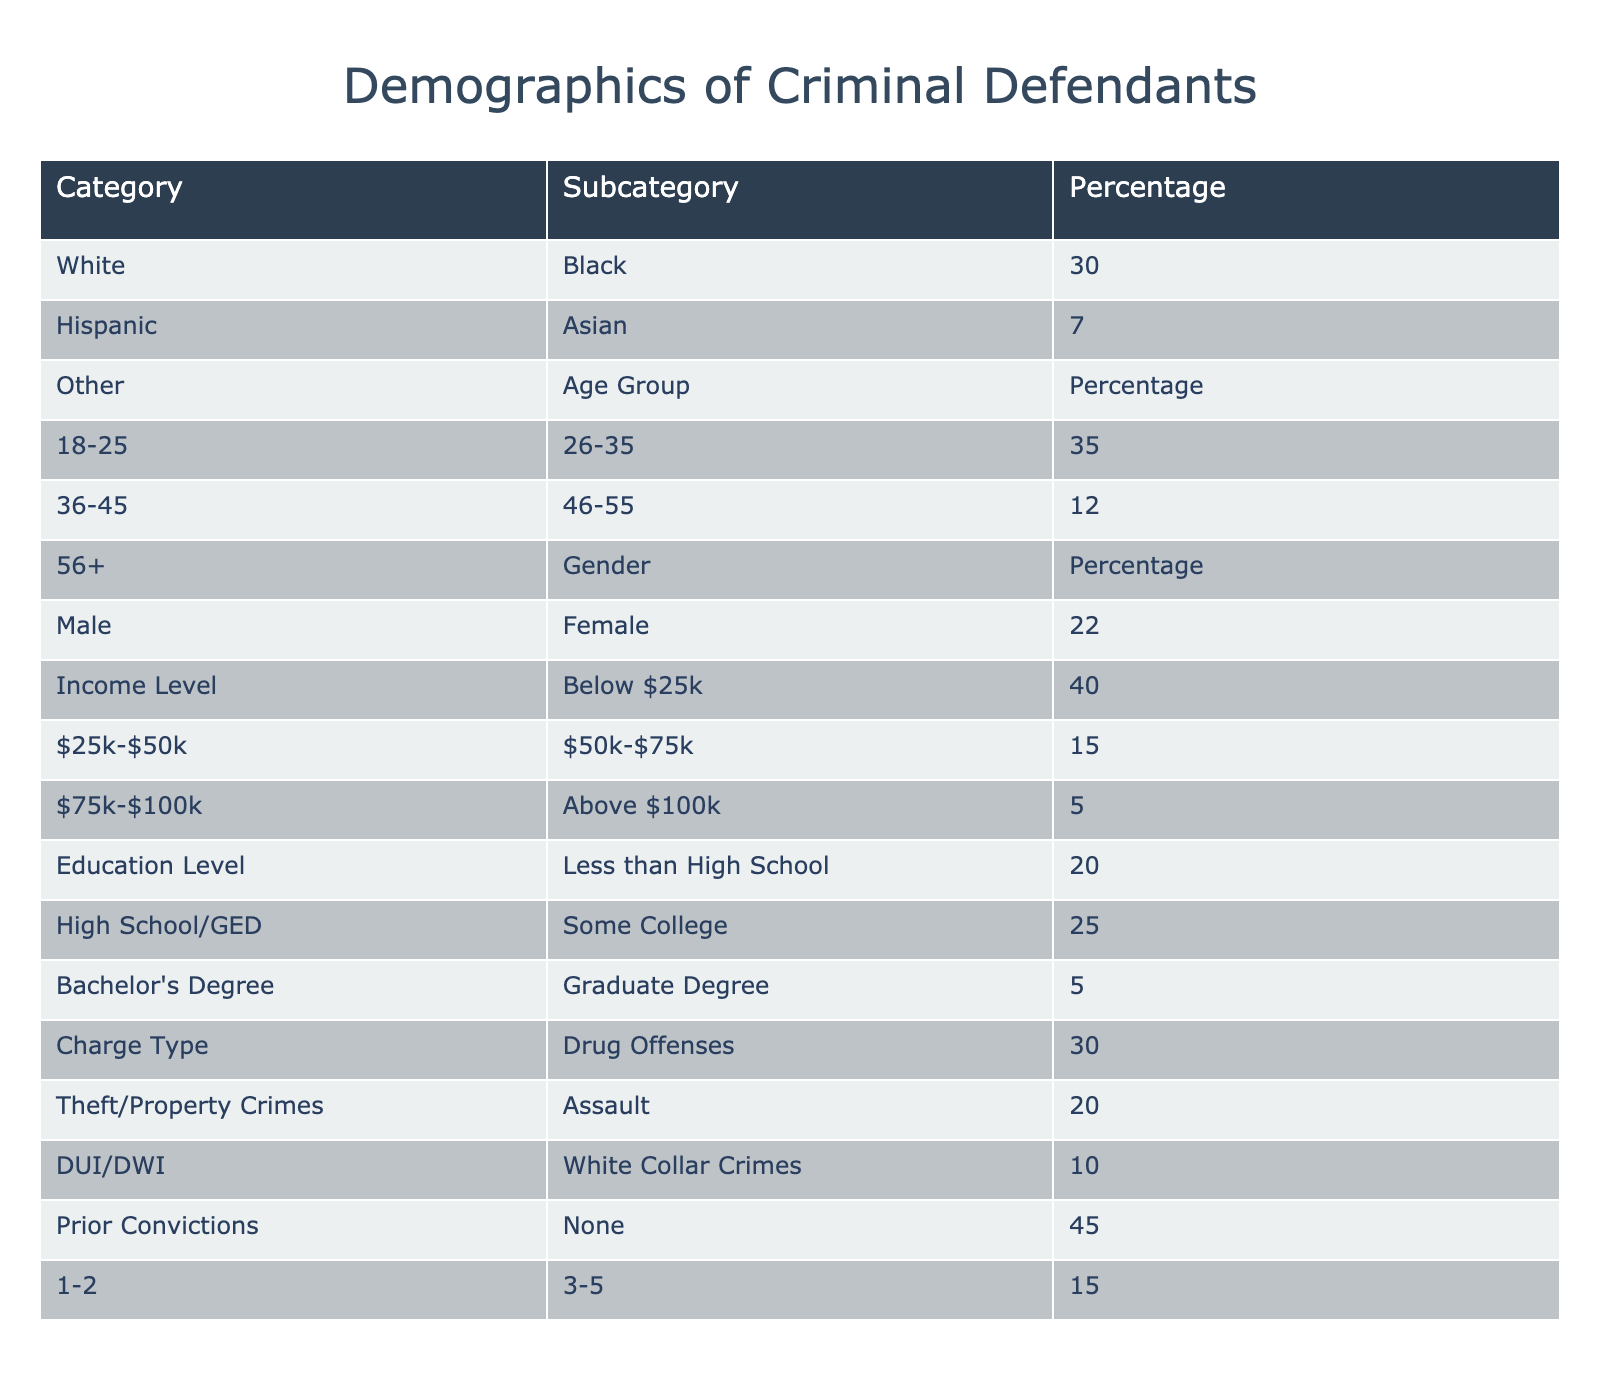What is the percentage of Black defendants? The table shows that the percentage of Black defendants is listed directly under the Race/Ethnicity category, and it states 30%.
Answer: 30% What percentage of defendants are 36 years old or older? To find this, we look at the Age Group percentages for the groups 36-45 (25%), 46-55 (12%), and 56+ (6%). Adding them: 25 + 12 + 6 = 43%.
Answer: 43% Are there more male defendants than female defendants? The table presents 78% male defendants and 22% female defendants. Since 78% is greater than 22%, the answer is yes.
Answer: Yes What is the combined percentage of defendants with a Bachelor's Degree or higher? The table lists 15% with a Bachelor's Degree and 5% with a Graduate Degree. Adding these gives: 15 + 5 = 20%.
Answer: 20% What race/ethnicity has the lowest representation among defendants? The table lists the races/ethnicities along with their percentages, revealing that 'Other' has the lowest representation at 3%.
Answer: Other What is the percentage of defendants with prior convictions of 1-2 and those with more than 5? The table specifies 30% have 1-2 prior convictions and 10% have more than 5. The combined percentage is 30 + 10 = 40%.
Answer: 40% What age group has the highest representation among defendants? The table indicates the age groups with their percentages, showing that the 26-35 age group has the highest at 35%.
Answer: 26-35 Is the majority of defendants earning below $50k? The table states 40% earn below $25k and 30% earn between $25k-$50k. Adding these, 40 + 30 = 70%, which is indeed the majority.
Answer: Yes What percentage of defendants are charged with White Collar Crimes? The table provides 10% for White Collar Crimes, as stated directly under Charge Type.
Answer: 10% What is the difference in representation between Drug Offenses and Assault charges? According to the table, Drug Offenses are at 30% and Assault at 20%. The difference is 30 - 20 = 10%.
Answer: 10% 